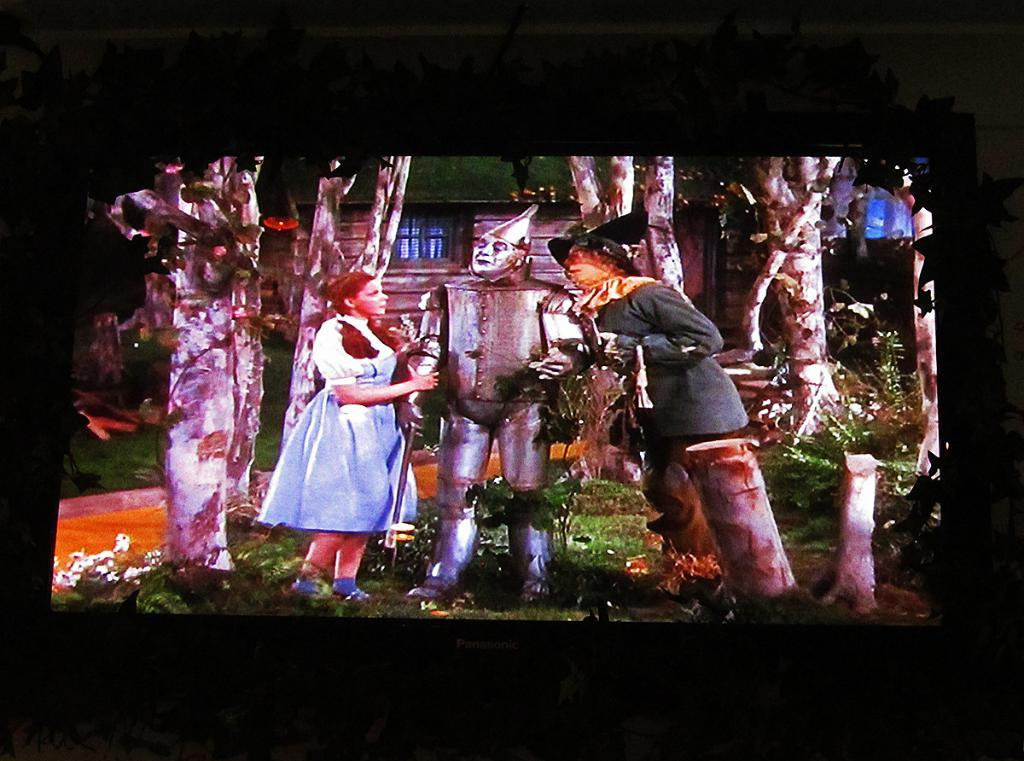How many people are in the image? There are two persons in the image. What other subject is present in the image besides the people? There is a robot in the image. Where are the people and robot located in the image? They are standing on the ground. What can be seen in the background of the image? There are trees and a house in the background of the image. What type of key is the robot holding in the image? There is no key present in the image; the robot is not holding anything. How many stars can be seen in the sky in the image? There is no sky visible in the image, so it is not possible to determine if there are any stars present. 